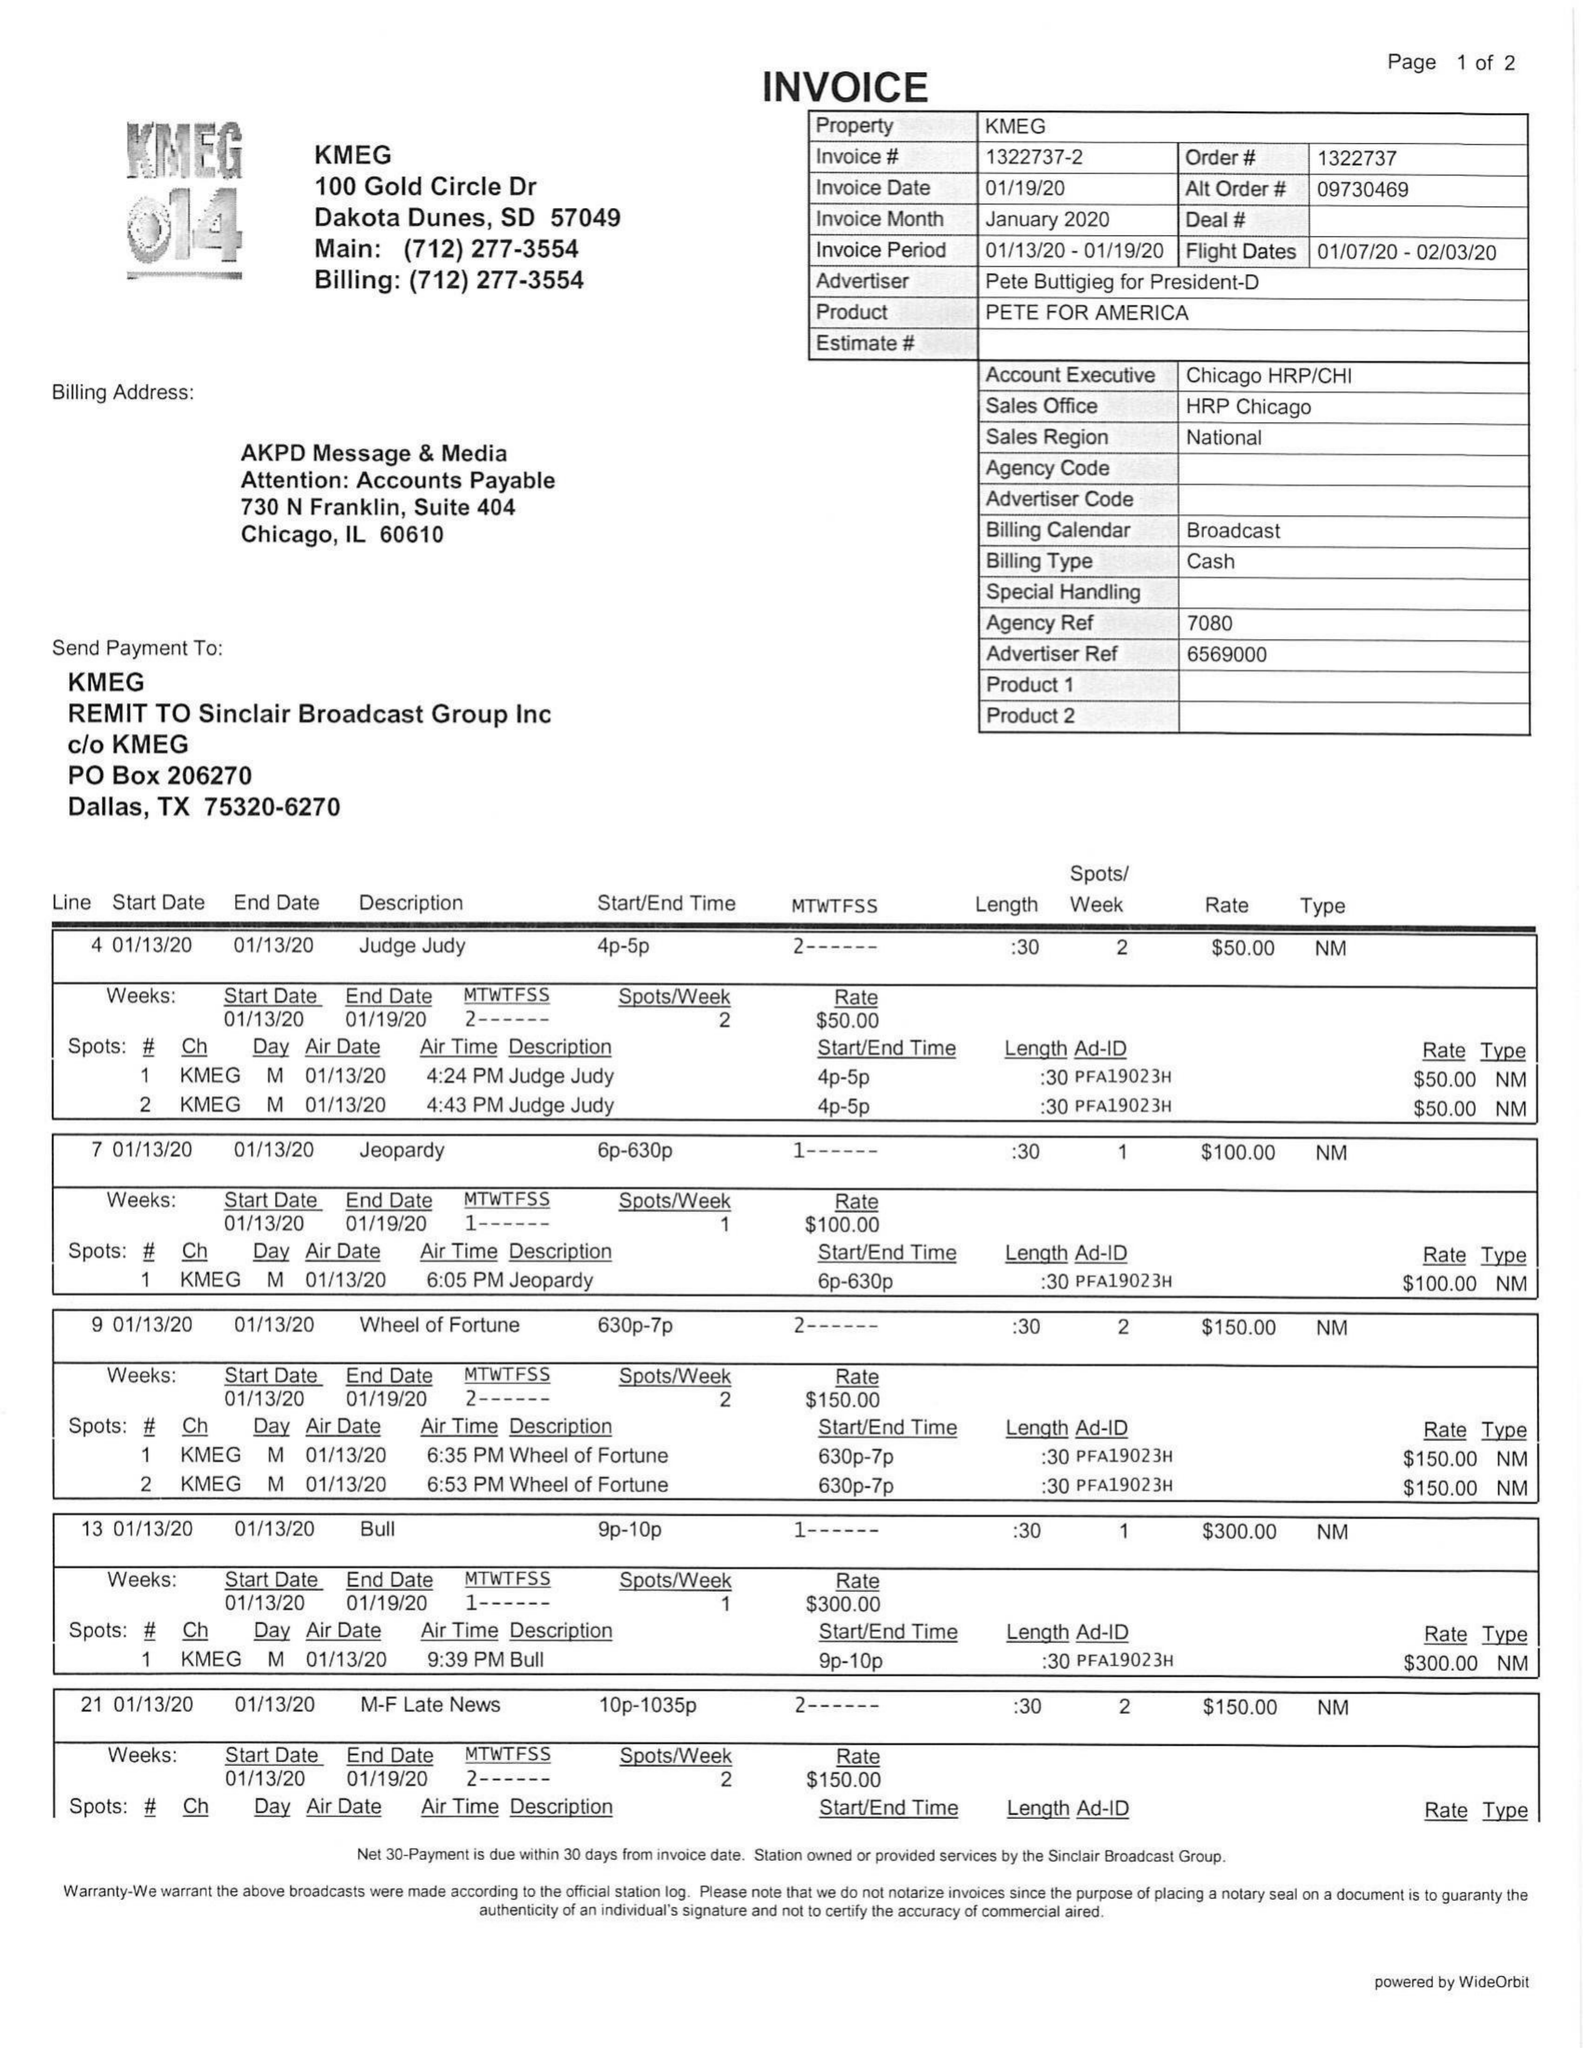What is the value for the flight_to?
Answer the question using a single word or phrase. 02/03/20 